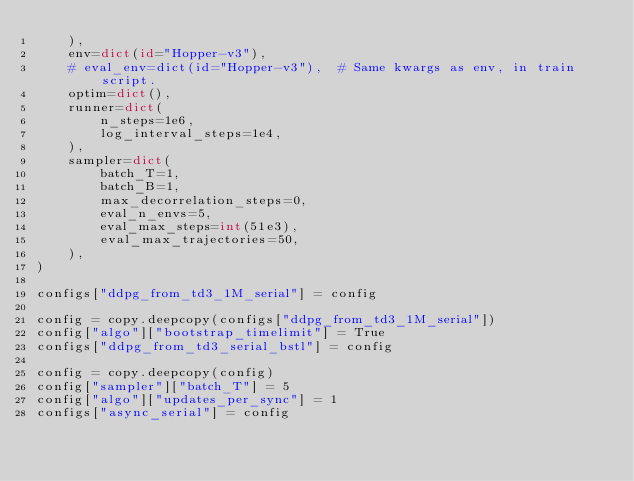<code> <loc_0><loc_0><loc_500><loc_500><_Python_>    ),
    env=dict(id="Hopper-v3"),
    # eval_env=dict(id="Hopper-v3"),  # Same kwargs as env, in train script.
    optim=dict(),
    runner=dict(
        n_steps=1e6,
        log_interval_steps=1e4,
    ),
    sampler=dict(
        batch_T=1,
        batch_B=1,
        max_decorrelation_steps=0,
        eval_n_envs=5,
        eval_max_steps=int(51e3),
        eval_max_trajectories=50,
    ),
)

configs["ddpg_from_td3_1M_serial"] = config

config = copy.deepcopy(configs["ddpg_from_td3_1M_serial"])
config["algo"]["bootstrap_timelimit"] = True
configs["ddpg_from_td3_serial_bstl"] = config

config = copy.deepcopy(config)
config["sampler"]["batch_T"] = 5
config["algo"]["updates_per_sync"] = 1
configs["async_serial"] = config
</code> 